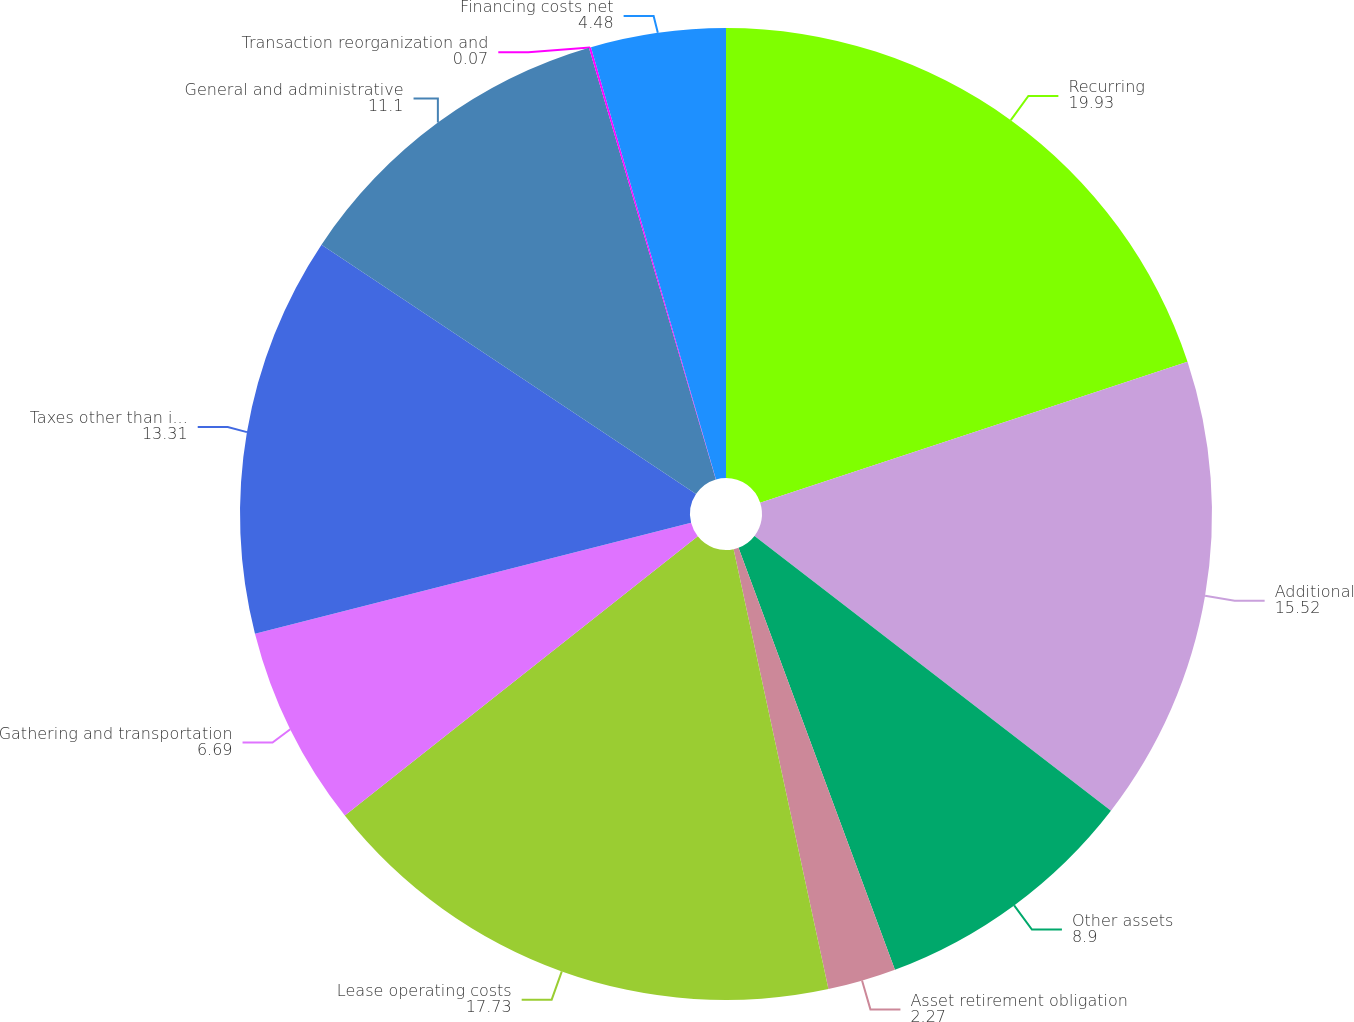Convert chart. <chart><loc_0><loc_0><loc_500><loc_500><pie_chart><fcel>Recurring<fcel>Additional<fcel>Other assets<fcel>Asset retirement obligation<fcel>Lease operating costs<fcel>Gathering and transportation<fcel>Taxes other than income<fcel>General and administrative<fcel>Transaction reorganization and<fcel>Financing costs net<nl><fcel>19.93%<fcel>15.52%<fcel>8.9%<fcel>2.27%<fcel>17.73%<fcel>6.69%<fcel>13.31%<fcel>11.1%<fcel>0.07%<fcel>4.48%<nl></chart> 